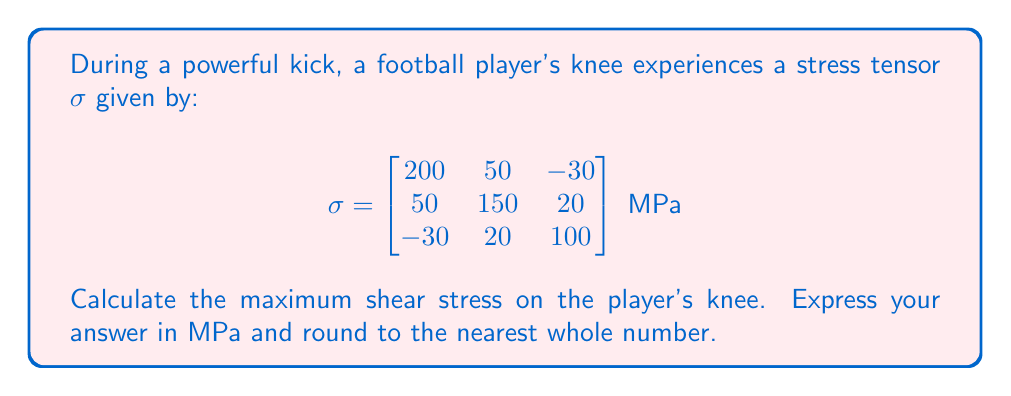Give your solution to this math problem. To find the maximum shear stress, we need to follow these steps:

1) First, we need to calculate the principal stresses. These are the eigenvalues of the stress tensor $\sigma$.

2) To find the eigenvalues, we solve the characteristic equation:
   $$\det(\sigma - \lambda I) = 0$$

3) Expanding this determinant gives us:
   $$(200-\lambda)(150-\lambda)(100-\lambda) - 50^2(100-\lambda) - (-30)^2(150-\lambda) - 20^2(200-\lambda) + 2(50)(-30)(20) = 0$$

4) Simplifying, we get the cubic equation:
   $$-\lambda^3 + 450\lambda^2 - 66500\lambda + 3195000 = 0$$

5) Solving this equation (using a calculator or computer algebra system) gives us the principal stresses:
   $$\lambda_1 \approx 237.8 \text{ MPa}, \lambda_2 \approx 133.6 \text{ MPa}, \lambda_3 \approx 78.6 \text{ MPa}$$

6) The maximum shear stress $\tau_{max}$ is given by half the difference between the largest and smallest principal stresses:

   $$\tau_{max} = \frac{1}{2}(\lambda_{max} - \lambda_{min}) = \frac{1}{2}(237.8 - 78.6) \approx 79.6 \text{ MPa}$$

7) Rounding to the nearest whole number gives us 80 MPa.
Answer: 80 MPa 